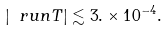<formula> <loc_0><loc_0><loc_500><loc_500>| \ r u n T | \lesssim 3 . \times 1 0 ^ { - 4 } .</formula> 